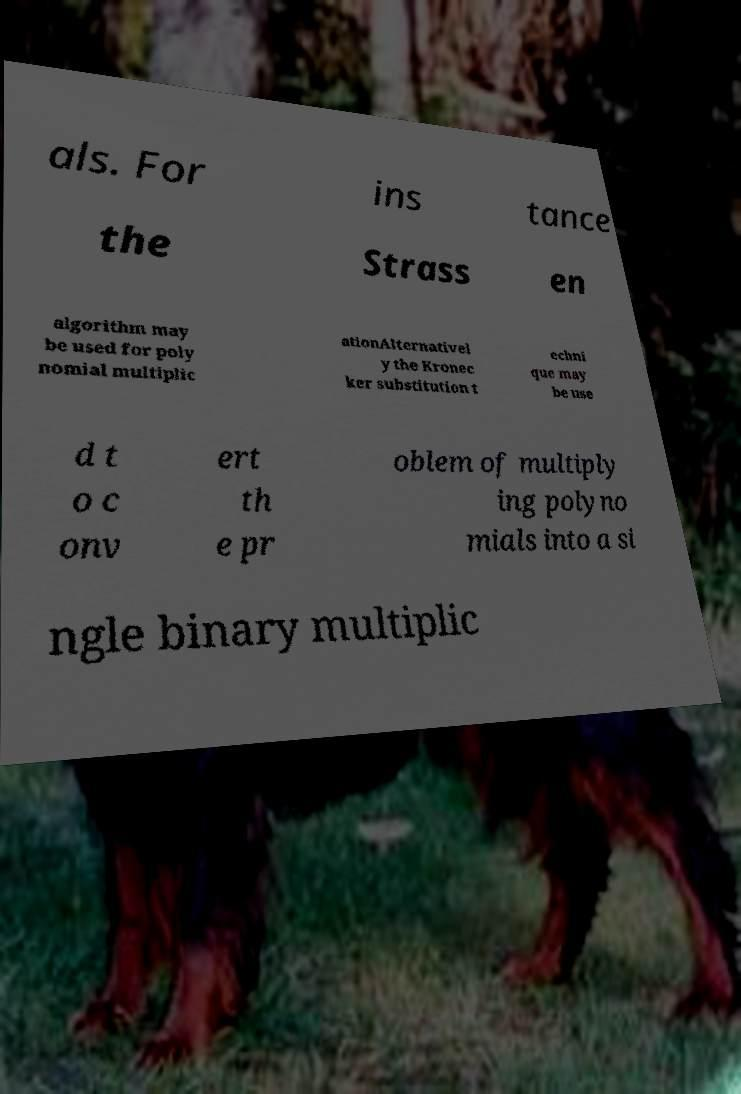Could you assist in decoding the text presented in this image and type it out clearly? als. For ins tance the Strass en algorithm may be used for poly nomial multiplic ationAlternativel y the Kronec ker substitution t echni que may be use d t o c onv ert th e pr oblem of multiply ing polyno mials into a si ngle binary multiplic 